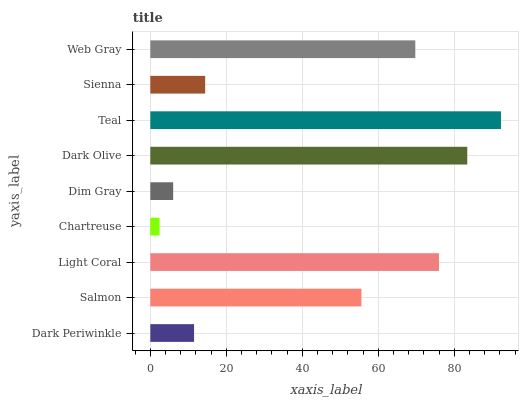Is Chartreuse the minimum?
Answer yes or no. Yes. Is Teal the maximum?
Answer yes or no. Yes. Is Salmon the minimum?
Answer yes or no. No. Is Salmon the maximum?
Answer yes or no. No. Is Salmon greater than Dark Periwinkle?
Answer yes or no. Yes. Is Dark Periwinkle less than Salmon?
Answer yes or no. Yes. Is Dark Periwinkle greater than Salmon?
Answer yes or no. No. Is Salmon less than Dark Periwinkle?
Answer yes or no. No. Is Salmon the high median?
Answer yes or no. Yes. Is Salmon the low median?
Answer yes or no. Yes. Is Chartreuse the high median?
Answer yes or no. No. Is Chartreuse the low median?
Answer yes or no. No. 